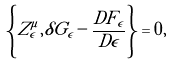Convert formula to latex. <formula><loc_0><loc_0><loc_500><loc_500>\left \{ Z ^ { \mu } _ { \epsilon } , \delta G _ { \epsilon } - \frac { D F _ { \epsilon } } { D \epsilon } \right \} = 0 ,</formula> 